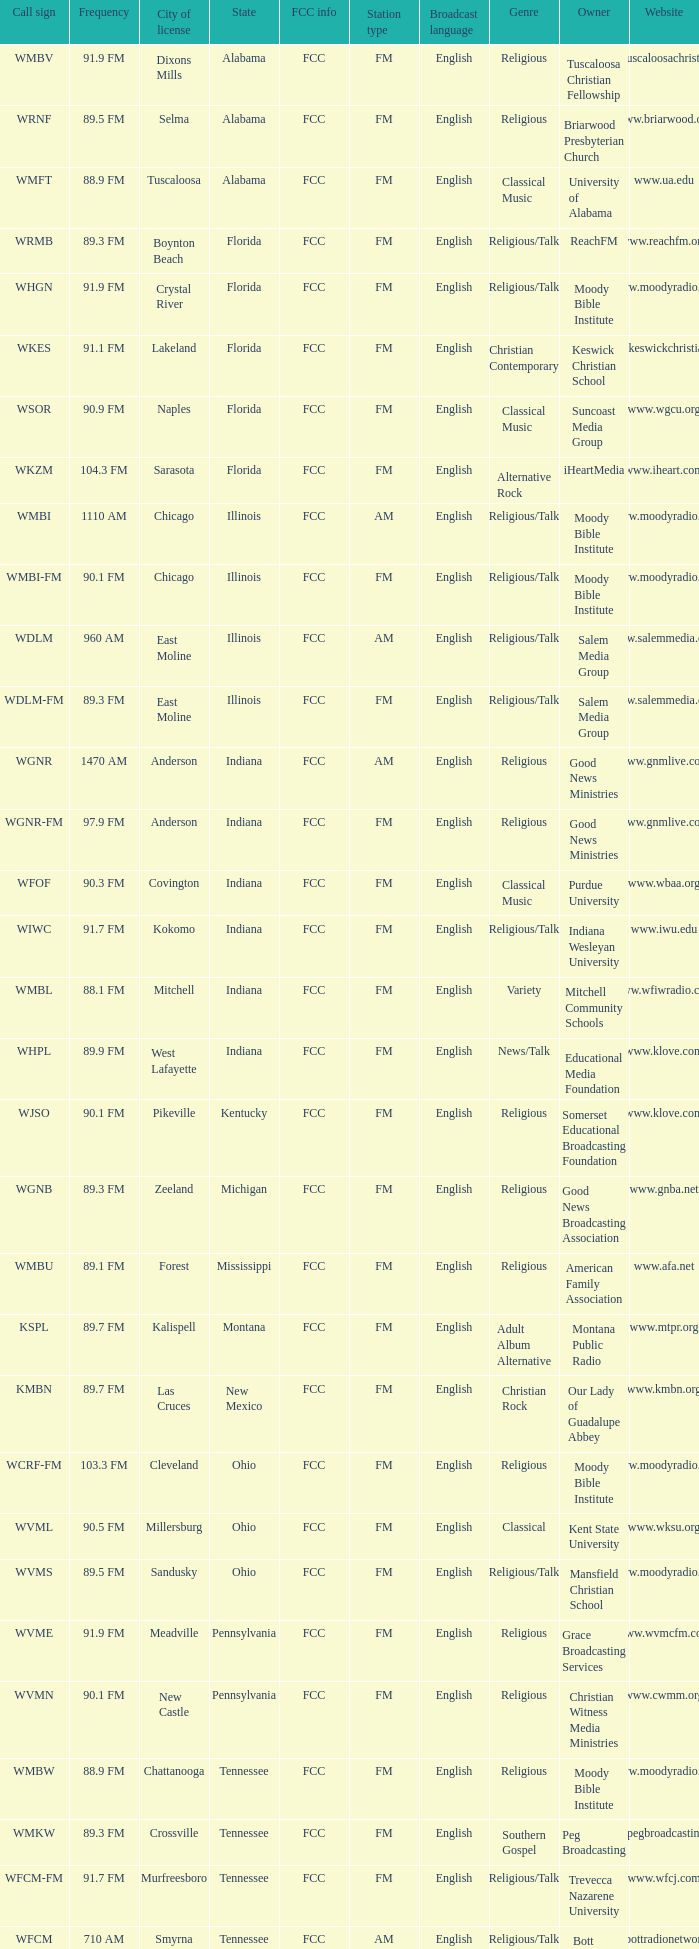What state is the radio station in that has a frequency of 90.1 FM and a city license in New Castle? Pennsylvania. 